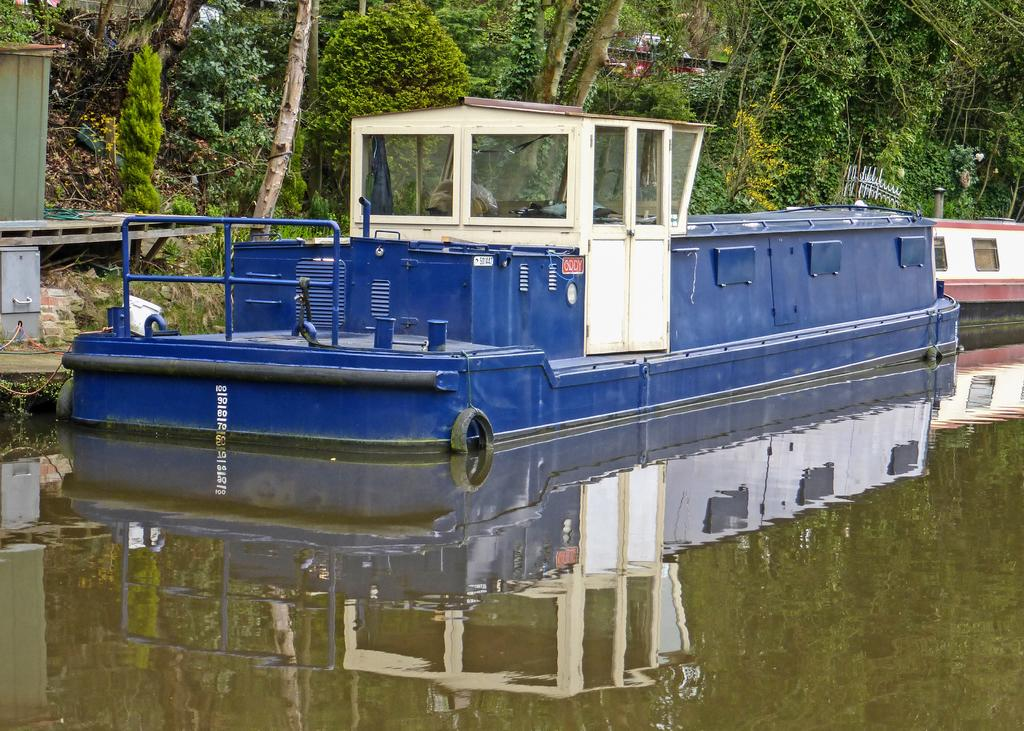What is the main subject of the image? The main subject of the image is ships. Where are the ships located? The ships are on a river. What can be seen in the background of the image? There are trees in the background of the image. What type of farm animals can be seen grazing near the ships in the image? There are no farm animals present in the image; it features ships on a river with trees in the background. 